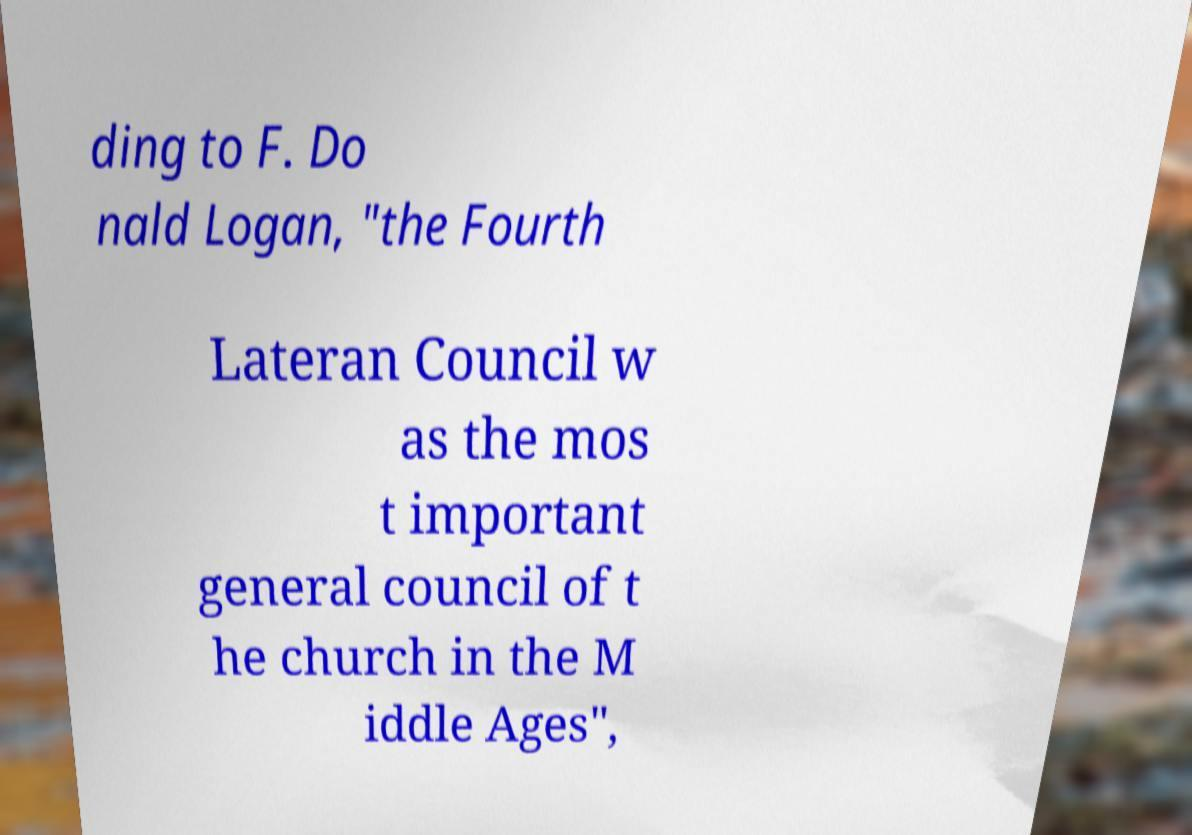Can you read and provide the text displayed in the image?This photo seems to have some interesting text. Can you extract and type it out for me? ding to F. Do nald Logan, "the Fourth Lateran Council w as the mos t important general council of t he church in the M iddle Ages", 